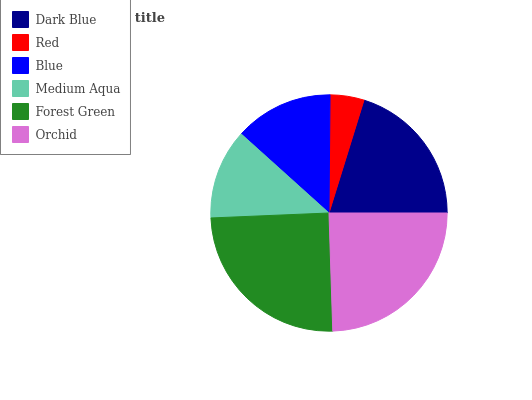Is Red the minimum?
Answer yes or no. Yes. Is Forest Green the maximum?
Answer yes or no. Yes. Is Blue the minimum?
Answer yes or no. No. Is Blue the maximum?
Answer yes or no. No. Is Blue greater than Red?
Answer yes or no. Yes. Is Red less than Blue?
Answer yes or no. Yes. Is Red greater than Blue?
Answer yes or no. No. Is Blue less than Red?
Answer yes or no. No. Is Dark Blue the high median?
Answer yes or no. Yes. Is Blue the low median?
Answer yes or no. Yes. Is Red the high median?
Answer yes or no. No. Is Red the low median?
Answer yes or no. No. 